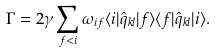<formula> <loc_0><loc_0><loc_500><loc_500>\Gamma = 2 { \gamma } \sum _ { f < i } \omega _ { i f } \langle i | { \hat { q } _ { k l } } | f \rangle \langle f | { \hat { q } } _ { k l } | i \rangle .</formula> 